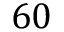<formula> <loc_0><loc_0><loc_500><loc_500>6 0</formula> 